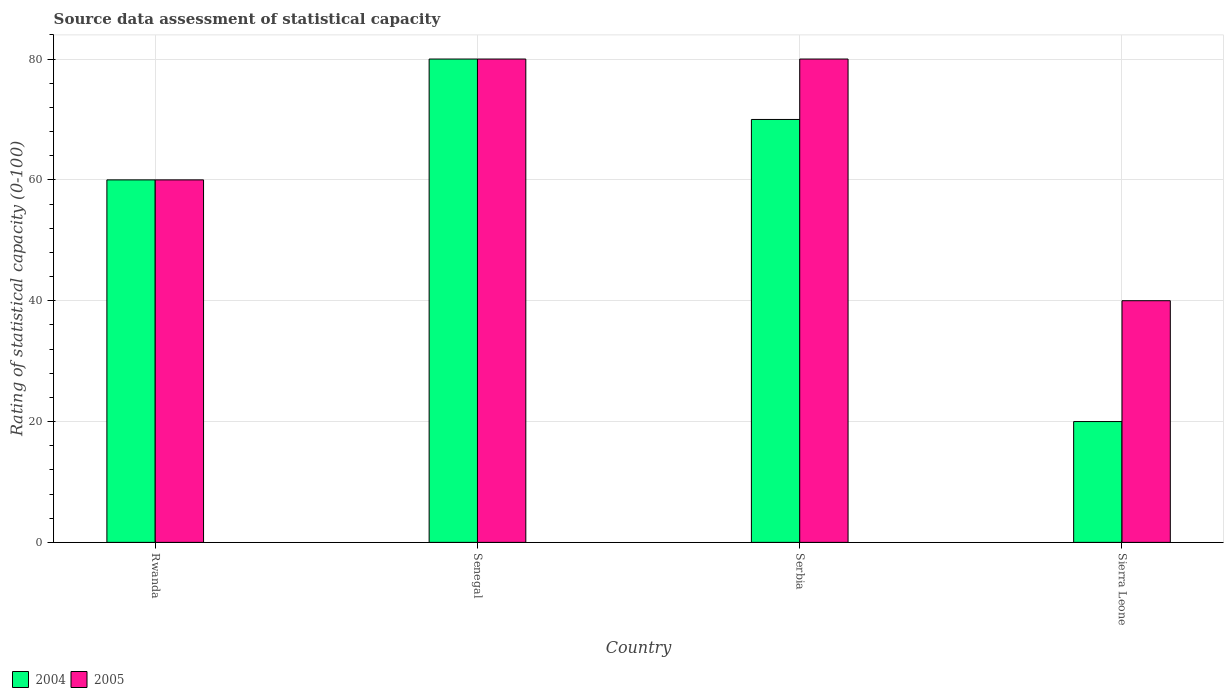How many groups of bars are there?
Offer a terse response. 4. Are the number of bars per tick equal to the number of legend labels?
Your answer should be very brief. Yes. What is the label of the 1st group of bars from the left?
Offer a terse response. Rwanda. What is the rating of statistical capacity in 2004 in Rwanda?
Provide a succinct answer. 60. In which country was the rating of statistical capacity in 2005 maximum?
Offer a very short reply. Senegal. In which country was the rating of statistical capacity in 2004 minimum?
Provide a short and direct response. Sierra Leone. What is the total rating of statistical capacity in 2005 in the graph?
Make the answer very short. 260. What is the difference between the rating of statistical capacity in 2004 in Senegal and that in Serbia?
Your response must be concise. 10. What is the difference between the rating of statistical capacity in 2004 in Sierra Leone and the rating of statistical capacity in 2005 in Serbia?
Give a very brief answer. -60. What is the average rating of statistical capacity in 2005 per country?
Provide a succinct answer. 65. What is the ratio of the rating of statistical capacity in 2005 in Rwanda to that in Senegal?
Ensure brevity in your answer.  0.75. Is the difference between the rating of statistical capacity in 2004 in Serbia and Sierra Leone greater than the difference between the rating of statistical capacity in 2005 in Serbia and Sierra Leone?
Your answer should be compact. Yes. What is the difference between the highest and the second highest rating of statistical capacity in 2004?
Provide a short and direct response. 20. What is the difference between the highest and the lowest rating of statistical capacity in 2004?
Your response must be concise. 60. In how many countries, is the rating of statistical capacity in 2005 greater than the average rating of statistical capacity in 2005 taken over all countries?
Ensure brevity in your answer.  2. Is the sum of the rating of statistical capacity in 2004 in Senegal and Serbia greater than the maximum rating of statistical capacity in 2005 across all countries?
Keep it short and to the point. Yes. What does the 1st bar from the right in Senegal represents?
Offer a very short reply. 2005. How many bars are there?
Offer a terse response. 8. How many countries are there in the graph?
Ensure brevity in your answer.  4. Are the values on the major ticks of Y-axis written in scientific E-notation?
Provide a succinct answer. No. Does the graph contain grids?
Your response must be concise. Yes. Where does the legend appear in the graph?
Make the answer very short. Bottom left. How many legend labels are there?
Provide a short and direct response. 2. What is the title of the graph?
Your response must be concise. Source data assessment of statistical capacity. Does "1994" appear as one of the legend labels in the graph?
Your answer should be compact. No. What is the label or title of the Y-axis?
Ensure brevity in your answer.  Rating of statistical capacity (0-100). What is the Rating of statistical capacity (0-100) of 2004 in Rwanda?
Make the answer very short. 60. What is the Rating of statistical capacity (0-100) of 2005 in Rwanda?
Your response must be concise. 60. What is the Rating of statistical capacity (0-100) in 2005 in Sierra Leone?
Provide a succinct answer. 40. Across all countries, what is the maximum Rating of statistical capacity (0-100) in 2005?
Provide a short and direct response. 80. Across all countries, what is the minimum Rating of statistical capacity (0-100) of 2004?
Keep it short and to the point. 20. Across all countries, what is the minimum Rating of statistical capacity (0-100) of 2005?
Ensure brevity in your answer.  40. What is the total Rating of statistical capacity (0-100) in 2004 in the graph?
Keep it short and to the point. 230. What is the total Rating of statistical capacity (0-100) of 2005 in the graph?
Provide a succinct answer. 260. What is the difference between the Rating of statistical capacity (0-100) of 2005 in Rwanda and that in Senegal?
Offer a very short reply. -20. What is the difference between the Rating of statistical capacity (0-100) in 2004 in Rwanda and that in Serbia?
Provide a succinct answer. -10. What is the difference between the Rating of statistical capacity (0-100) of 2005 in Rwanda and that in Serbia?
Provide a succinct answer. -20. What is the difference between the Rating of statistical capacity (0-100) of 2005 in Rwanda and that in Sierra Leone?
Offer a terse response. 20. What is the difference between the Rating of statistical capacity (0-100) of 2004 in Senegal and that in Serbia?
Ensure brevity in your answer.  10. What is the difference between the Rating of statistical capacity (0-100) of 2005 in Senegal and that in Serbia?
Your answer should be very brief. 0. What is the difference between the Rating of statistical capacity (0-100) in 2005 in Serbia and that in Sierra Leone?
Offer a terse response. 40. What is the difference between the Rating of statistical capacity (0-100) of 2004 in Senegal and the Rating of statistical capacity (0-100) of 2005 in Serbia?
Provide a succinct answer. 0. What is the difference between the Rating of statistical capacity (0-100) of 2004 in Senegal and the Rating of statistical capacity (0-100) of 2005 in Sierra Leone?
Offer a very short reply. 40. What is the average Rating of statistical capacity (0-100) of 2004 per country?
Keep it short and to the point. 57.5. What is the average Rating of statistical capacity (0-100) of 2005 per country?
Provide a short and direct response. 65. What is the difference between the Rating of statistical capacity (0-100) in 2004 and Rating of statistical capacity (0-100) in 2005 in Rwanda?
Keep it short and to the point. 0. What is the difference between the Rating of statistical capacity (0-100) of 2004 and Rating of statistical capacity (0-100) of 2005 in Senegal?
Offer a terse response. 0. What is the ratio of the Rating of statistical capacity (0-100) in 2004 in Rwanda to that in Serbia?
Make the answer very short. 0.86. What is the ratio of the Rating of statistical capacity (0-100) of 2005 in Rwanda to that in Serbia?
Make the answer very short. 0.75. What is the ratio of the Rating of statistical capacity (0-100) of 2004 in Rwanda to that in Sierra Leone?
Give a very brief answer. 3. What is the ratio of the Rating of statistical capacity (0-100) of 2004 in Senegal to that in Serbia?
Your answer should be compact. 1.14. What is the ratio of the Rating of statistical capacity (0-100) in 2005 in Senegal to that in Serbia?
Your answer should be very brief. 1. What is the ratio of the Rating of statistical capacity (0-100) in 2004 in Senegal to that in Sierra Leone?
Your answer should be compact. 4. What is the ratio of the Rating of statistical capacity (0-100) of 2004 in Serbia to that in Sierra Leone?
Your response must be concise. 3.5. What is the difference between the highest and the second highest Rating of statistical capacity (0-100) of 2004?
Give a very brief answer. 10. What is the difference between the highest and the second highest Rating of statistical capacity (0-100) in 2005?
Your answer should be compact. 0. What is the difference between the highest and the lowest Rating of statistical capacity (0-100) of 2004?
Make the answer very short. 60. What is the difference between the highest and the lowest Rating of statistical capacity (0-100) of 2005?
Ensure brevity in your answer.  40. 